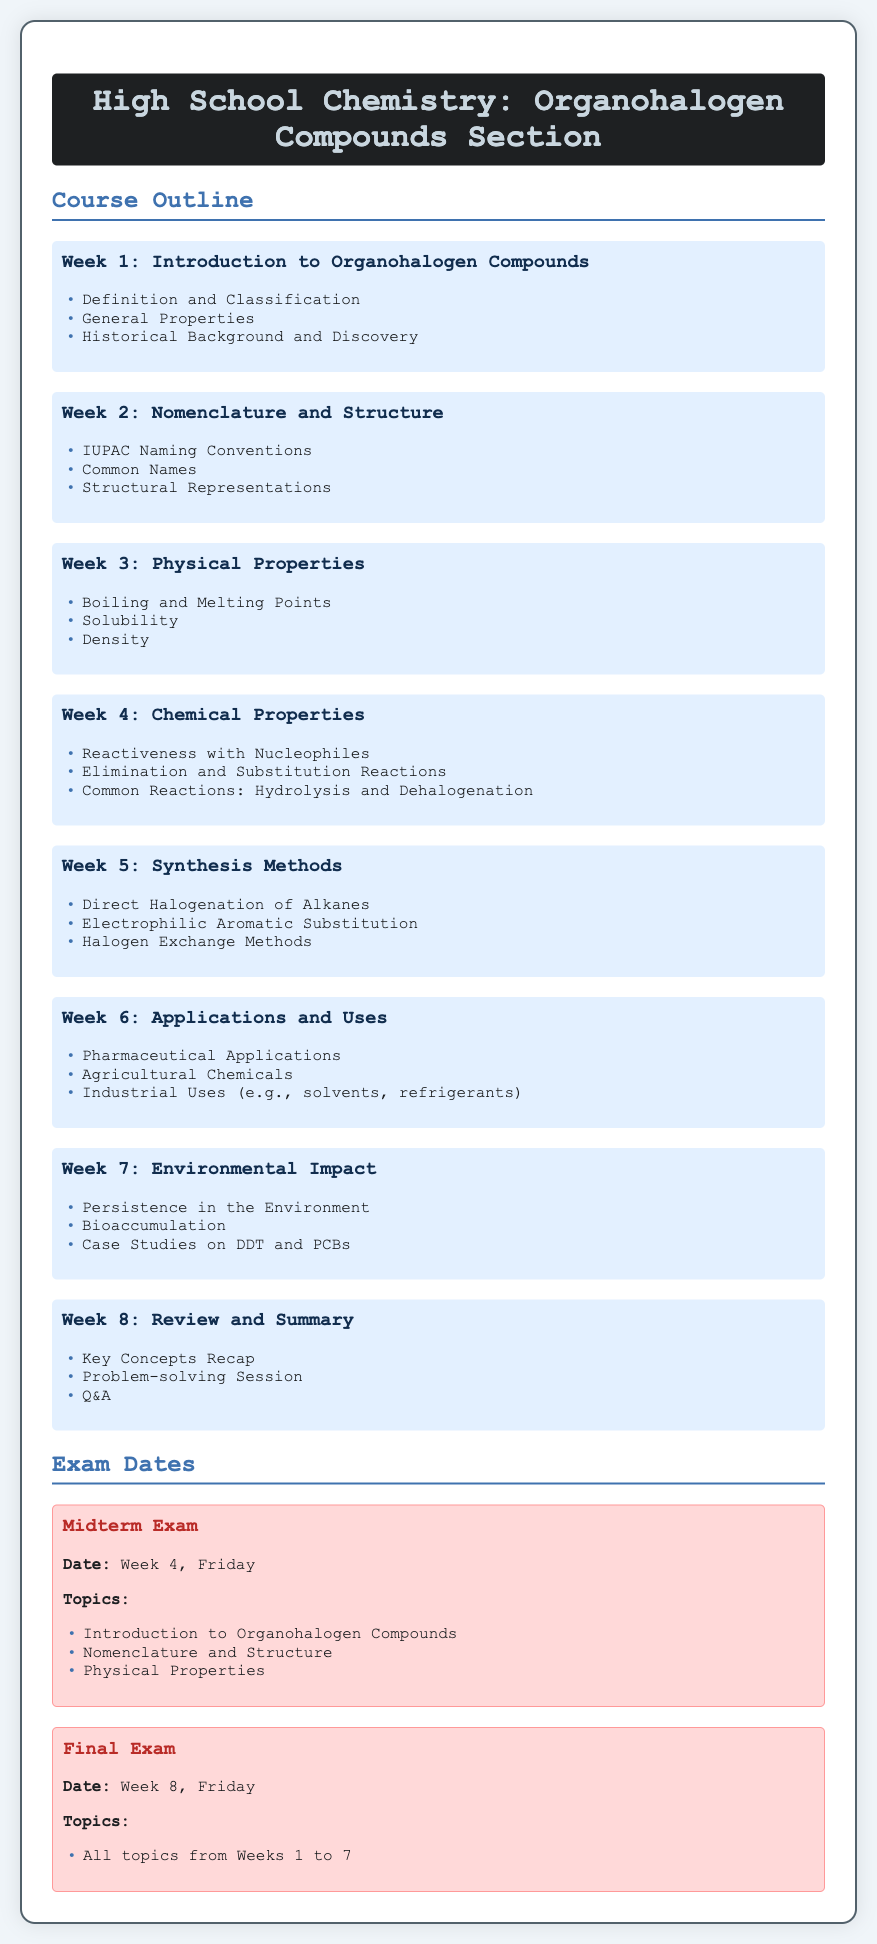What is the main topic of the course outline? The main topic of the course outline is "Organohalogen Compounds."
Answer: Organohalogen Compounds How many weeks does the syllabus cover? The syllabus covers a total of eight weeks.
Answer: Eight weeks What is the title of Week 6’s focus? Week 6 focuses on applications and uses of organohalogen compounds.
Answer: Applications and Uses When is the Midterm Exam scheduled? The Midterm Exam is scheduled for Week 4 on Friday.
Answer: Week 4, Friday What reaction types are studied in Week 4? The reaction types include elimination and substitution reactions.
Answer: Elimination and Substitution Reactions Which compounds are mentioned in the environmental impact case studies? The compounds mentioned are DDT and PCBs.
Answer: DDT and PCBs What topic is covered in Week 1? Week 1 covers the introduction to organohalogen compounds, including their definition and classification.
Answer: Introduction to Organohalogen Compounds How are common names discussed in the syllabus? Common names are discussed in Week 2 under nomenclature and structure.
Answer: Nomenclature and Structure What is the focus of Week 8? Week 8 focuses on review and summary of key concepts.
Answer: Review and Summary 